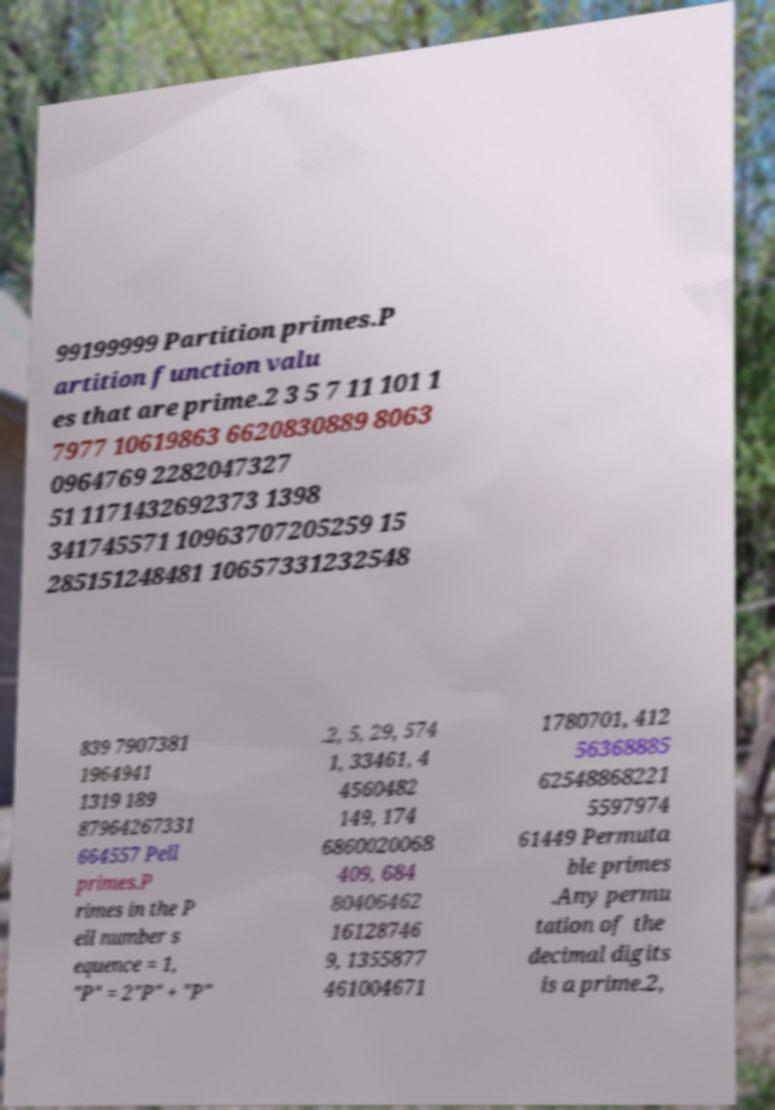Could you assist in decoding the text presented in this image and type it out clearly? 99199999 Partition primes.P artition function valu es that are prime.2 3 5 7 11 101 1 7977 10619863 6620830889 8063 0964769 2282047327 51 1171432692373 1398 341745571 10963707205259 15 285151248481 10657331232548 839 7907381 1964941 1319 189 87964267331 664557 Pell primes.P rimes in the P ell number s equence = 1, "P" = 2"P" + "P" .2, 5, 29, 574 1, 33461, 4 4560482 149, 174 6860020068 409, 684 80406462 16128746 9, 1355877 461004671 1780701, 412 56368885 62548868221 5597974 61449 Permuta ble primes .Any permu tation of the decimal digits is a prime.2, 